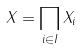<formula> <loc_0><loc_0><loc_500><loc_500>X = \prod _ { i \in I } X _ { i }</formula> 